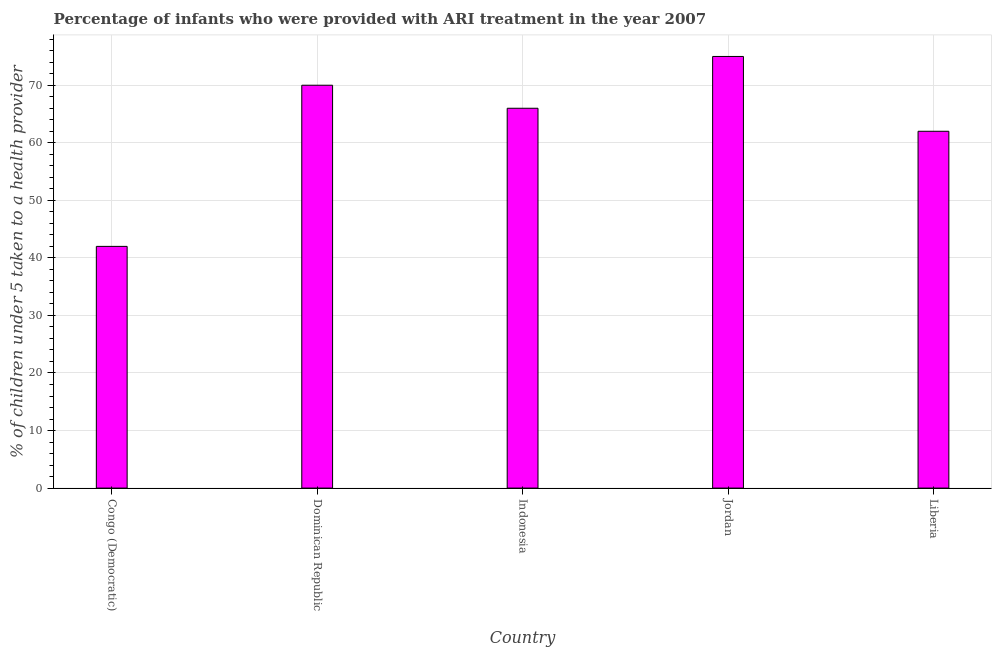Does the graph contain any zero values?
Your answer should be very brief. No. What is the title of the graph?
Make the answer very short. Percentage of infants who were provided with ARI treatment in the year 2007. What is the label or title of the Y-axis?
Ensure brevity in your answer.  % of children under 5 taken to a health provider. What is the percentage of children who were provided with ari treatment in Jordan?
Your answer should be compact. 75. Across all countries, what is the maximum percentage of children who were provided with ari treatment?
Ensure brevity in your answer.  75. Across all countries, what is the minimum percentage of children who were provided with ari treatment?
Offer a very short reply. 42. In which country was the percentage of children who were provided with ari treatment maximum?
Offer a terse response. Jordan. In which country was the percentage of children who were provided with ari treatment minimum?
Give a very brief answer. Congo (Democratic). What is the sum of the percentage of children who were provided with ari treatment?
Your response must be concise. 315. In how many countries, is the percentage of children who were provided with ari treatment greater than 74 %?
Provide a short and direct response. 1. What is the ratio of the percentage of children who were provided with ari treatment in Jordan to that in Liberia?
Offer a very short reply. 1.21. Is the percentage of children who were provided with ari treatment in Indonesia less than that in Jordan?
Keep it short and to the point. Yes. What is the difference between the highest and the second highest percentage of children who were provided with ari treatment?
Provide a succinct answer. 5. Is the sum of the percentage of children who were provided with ari treatment in Congo (Democratic) and Dominican Republic greater than the maximum percentage of children who were provided with ari treatment across all countries?
Your answer should be very brief. Yes. What is the difference between the highest and the lowest percentage of children who were provided with ari treatment?
Offer a very short reply. 33. In how many countries, is the percentage of children who were provided with ari treatment greater than the average percentage of children who were provided with ari treatment taken over all countries?
Make the answer very short. 3. Are all the bars in the graph horizontal?
Make the answer very short. No. What is the difference between two consecutive major ticks on the Y-axis?
Provide a short and direct response. 10. Are the values on the major ticks of Y-axis written in scientific E-notation?
Provide a short and direct response. No. What is the % of children under 5 taken to a health provider in Indonesia?
Make the answer very short. 66. What is the % of children under 5 taken to a health provider in Liberia?
Give a very brief answer. 62. What is the difference between the % of children under 5 taken to a health provider in Congo (Democratic) and Dominican Republic?
Keep it short and to the point. -28. What is the difference between the % of children under 5 taken to a health provider in Congo (Democratic) and Indonesia?
Provide a short and direct response. -24. What is the difference between the % of children under 5 taken to a health provider in Congo (Democratic) and Jordan?
Your response must be concise. -33. What is the difference between the % of children under 5 taken to a health provider in Dominican Republic and Indonesia?
Your answer should be compact. 4. What is the difference between the % of children under 5 taken to a health provider in Dominican Republic and Jordan?
Your answer should be very brief. -5. What is the difference between the % of children under 5 taken to a health provider in Dominican Republic and Liberia?
Your answer should be very brief. 8. What is the difference between the % of children under 5 taken to a health provider in Indonesia and Jordan?
Ensure brevity in your answer.  -9. What is the ratio of the % of children under 5 taken to a health provider in Congo (Democratic) to that in Indonesia?
Your response must be concise. 0.64. What is the ratio of the % of children under 5 taken to a health provider in Congo (Democratic) to that in Jordan?
Offer a very short reply. 0.56. What is the ratio of the % of children under 5 taken to a health provider in Congo (Democratic) to that in Liberia?
Provide a succinct answer. 0.68. What is the ratio of the % of children under 5 taken to a health provider in Dominican Republic to that in Indonesia?
Make the answer very short. 1.06. What is the ratio of the % of children under 5 taken to a health provider in Dominican Republic to that in Jordan?
Provide a succinct answer. 0.93. What is the ratio of the % of children under 5 taken to a health provider in Dominican Republic to that in Liberia?
Offer a very short reply. 1.13. What is the ratio of the % of children under 5 taken to a health provider in Indonesia to that in Liberia?
Your answer should be compact. 1.06. What is the ratio of the % of children under 5 taken to a health provider in Jordan to that in Liberia?
Provide a short and direct response. 1.21. 